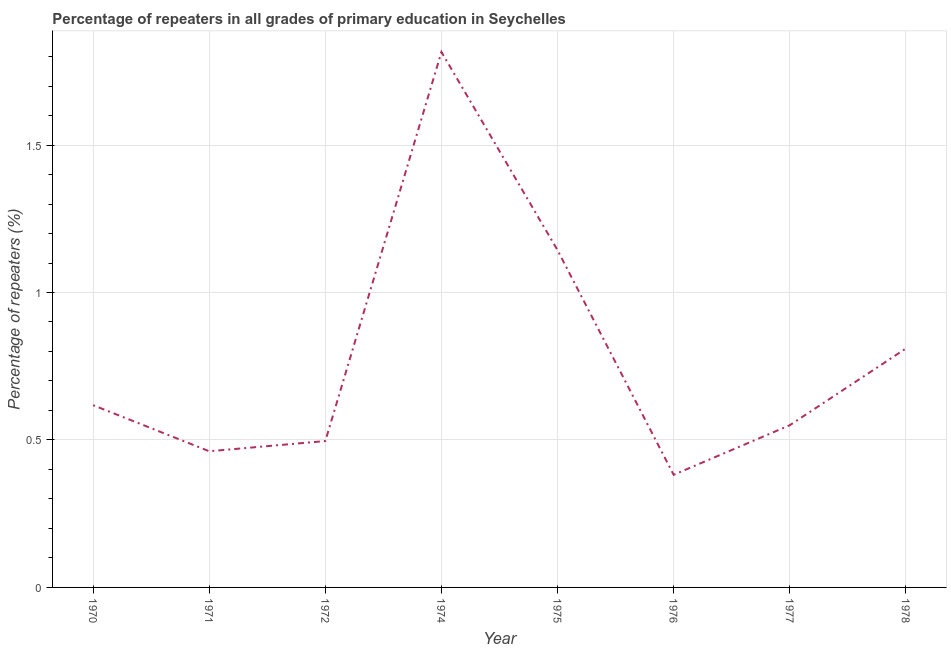What is the percentage of repeaters in primary education in 1978?
Make the answer very short. 0.81. Across all years, what is the maximum percentage of repeaters in primary education?
Provide a succinct answer. 1.82. Across all years, what is the minimum percentage of repeaters in primary education?
Your answer should be compact. 0.38. In which year was the percentage of repeaters in primary education maximum?
Provide a short and direct response. 1974. In which year was the percentage of repeaters in primary education minimum?
Provide a short and direct response. 1976. What is the sum of the percentage of repeaters in primary education?
Your response must be concise. 6.28. What is the difference between the percentage of repeaters in primary education in 1977 and 1978?
Ensure brevity in your answer.  -0.26. What is the average percentage of repeaters in primary education per year?
Ensure brevity in your answer.  0.78. What is the median percentage of repeaters in primary education?
Keep it short and to the point. 0.58. What is the ratio of the percentage of repeaters in primary education in 1975 to that in 1978?
Your answer should be very brief. 1.41. Is the difference between the percentage of repeaters in primary education in 1970 and 1971 greater than the difference between any two years?
Offer a terse response. No. What is the difference between the highest and the second highest percentage of repeaters in primary education?
Offer a very short reply. 0.67. Is the sum of the percentage of repeaters in primary education in 1975 and 1978 greater than the maximum percentage of repeaters in primary education across all years?
Make the answer very short. Yes. What is the difference between the highest and the lowest percentage of repeaters in primary education?
Offer a terse response. 1.43. In how many years, is the percentage of repeaters in primary education greater than the average percentage of repeaters in primary education taken over all years?
Your answer should be compact. 3. How many lines are there?
Provide a short and direct response. 1. Are the values on the major ticks of Y-axis written in scientific E-notation?
Your answer should be very brief. No. What is the title of the graph?
Your answer should be very brief. Percentage of repeaters in all grades of primary education in Seychelles. What is the label or title of the X-axis?
Your response must be concise. Year. What is the label or title of the Y-axis?
Provide a short and direct response. Percentage of repeaters (%). What is the Percentage of repeaters (%) of 1970?
Keep it short and to the point. 0.62. What is the Percentage of repeaters (%) of 1971?
Your response must be concise. 0.46. What is the Percentage of repeaters (%) in 1972?
Ensure brevity in your answer.  0.5. What is the Percentage of repeaters (%) of 1974?
Provide a succinct answer. 1.82. What is the Percentage of repeaters (%) of 1975?
Keep it short and to the point. 1.14. What is the Percentage of repeaters (%) of 1976?
Provide a short and direct response. 0.38. What is the Percentage of repeaters (%) of 1977?
Offer a terse response. 0.55. What is the Percentage of repeaters (%) of 1978?
Offer a terse response. 0.81. What is the difference between the Percentage of repeaters (%) in 1970 and 1971?
Give a very brief answer. 0.16. What is the difference between the Percentage of repeaters (%) in 1970 and 1972?
Offer a terse response. 0.12. What is the difference between the Percentage of repeaters (%) in 1970 and 1974?
Provide a succinct answer. -1.2. What is the difference between the Percentage of repeaters (%) in 1970 and 1975?
Your answer should be compact. -0.53. What is the difference between the Percentage of repeaters (%) in 1970 and 1976?
Offer a terse response. 0.24. What is the difference between the Percentage of repeaters (%) in 1970 and 1977?
Provide a succinct answer. 0.07. What is the difference between the Percentage of repeaters (%) in 1970 and 1978?
Your response must be concise. -0.19. What is the difference between the Percentage of repeaters (%) in 1971 and 1972?
Your answer should be very brief. -0.03. What is the difference between the Percentage of repeaters (%) in 1971 and 1974?
Provide a short and direct response. -1.35. What is the difference between the Percentage of repeaters (%) in 1971 and 1975?
Provide a short and direct response. -0.68. What is the difference between the Percentage of repeaters (%) in 1971 and 1976?
Ensure brevity in your answer.  0.08. What is the difference between the Percentage of repeaters (%) in 1971 and 1977?
Your response must be concise. -0.09. What is the difference between the Percentage of repeaters (%) in 1971 and 1978?
Ensure brevity in your answer.  -0.35. What is the difference between the Percentage of repeaters (%) in 1972 and 1974?
Your answer should be very brief. -1.32. What is the difference between the Percentage of repeaters (%) in 1972 and 1975?
Your answer should be very brief. -0.65. What is the difference between the Percentage of repeaters (%) in 1972 and 1976?
Your response must be concise. 0.11. What is the difference between the Percentage of repeaters (%) in 1972 and 1977?
Your answer should be very brief. -0.05. What is the difference between the Percentage of repeaters (%) in 1972 and 1978?
Your response must be concise. -0.31. What is the difference between the Percentage of repeaters (%) in 1974 and 1975?
Ensure brevity in your answer.  0.67. What is the difference between the Percentage of repeaters (%) in 1974 and 1976?
Your answer should be very brief. 1.43. What is the difference between the Percentage of repeaters (%) in 1974 and 1977?
Your response must be concise. 1.27. What is the difference between the Percentage of repeaters (%) in 1974 and 1978?
Make the answer very short. 1.01. What is the difference between the Percentage of repeaters (%) in 1975 and 1976?
Provide a succinct answer. 0.76. What is the difference between the Percentage of repeaters (%) in 1975 and 1977?
Your response must be concise. 0.59. What is the difference between the Percentage of repeaters (%) in 1975 and 1978?
Make the answer very short. 0.33. What is the difference between the Percentage of repeaters (%) in 1976 and 1977?
Offer a very short reply. -0.17. What is the difference between the Percentage of repeaters (%) in 1976 and 1978?
Give a very brief answer. -0.43. What is the difference between the Percentage of repeaters (%) in 1977 and 1978?
Your answer should be very brief. -0.26. What is the ratio of the Percentage of repeaters (%) in 1970 to that in 1971?
Your answer should be very brief. 1.34. What is the ratio of the Percentage of repeaters (%) in 1970 to that in 1972?
Your response must be concise. 1.25. What is the ratio of the Percentage of repeaters (%) in 1970 to that in 1974?
Give a very brief answer. 0.34. What is the ratio of the Percentage of repeaters (%) in 1970 to that in 1975?
Your answer should be compact. 0.54. What is the ratio of the Percentage of repeaters (%) in 1970 to that in 1976?
Provide a short and direct response. 1.62. What is the ratio of the Percentage of repeaters (%) in 1970 to that in 1977?
Provide a short and direct response. 1.12. What is the ratio of the Percentage of repeaters (%) in 1970 to that in 1978?
Ensure brevity in your answer.  0.76. What is the ratio of the Percentage of repeaters (%) in 1971 to that in 1974?
Provide a succinct answer. 0.25. What is the ratio of the Percentage of repeaters (%) in 1971 to that in 1975?
Provide a succinct answer. 0.4. What is the ratio of the Percentage of repeaters (%) in 1971 to that in 1976?
Provide a short and direct response. 1.21. What is the ratio of the Percentage of repeaters (%) in 1971 to that in 1977?
Your answer should be compact. 0.84. What is the ratio of the Percentage of repeaters (%) in 1971 to that in 1978?
Give a very brief answer. 0.57. What is the ratio of the Percentage of repeaters (%) in 1972 to that in 1974?
Your answer should be very brief. 0.27. What is the ratio of the Percentage of repeaters (%) in 1972 to that in 1975?
Ensure brevity in your answer.  0.43. What is the ratio of the Percentage of repeaters (%) in 1972 to that in 1976?
Provide a succinct answer. 1.3. What is the ratio of the Percentage of repeaters (%) in 1972 to that in 1977?
Your answer should be compact. 0.9. What is the ratio of the Percentage of repeaters (%) in 1972 to that in 1978?
Give a very brief answer. 0.61. What is the ratio of the Percentage of repeaters (%) in 1974 to that in 1975?
Offer a terse response. 1.59. What is the ratio of the Percentage of repeaters (%) in 1974 to that in 1976?
Give a very brief answer. 4.75. What is the ratio of the Percentage of repeaters (%) in 1974 to that in 1977?
Provide a short and direct response. 3.3. What is the ratio of the Percentage of repeaters (%) in 1974 to that in 1978?
Ensure brevity in your answer.  2.24. What is the ratio of the Percentage of repeaters (%) in 1975 to that in 1976?
Keep it short and to the point. 2.99. What is the ratio of the Percentage of repeaters (%) in 1975 to that in 1977?
Give a very brief answer. 2.08. What is the ratio of the Percentage of repeaters (%) in 1975 to that in 1978?
Offer a very short reply. 1.41. What is the ratio of the Percentage of repeaters (%) in 1976 to that in 1977?
Your response must be concise. 0.69. What is the ratio of the Percentage of repeaters (%) in 1976 to that in 1978?
Your response must be concise. 0.47. What is the ratio of the Percentage of repeaters (%) in 1977 to that in 1978?
Offer a very short reply. 0.68. 